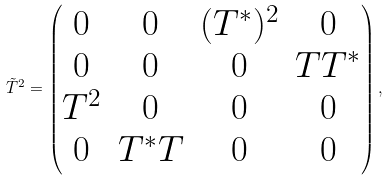<formula> <loc_0><loc_0><loc_500><loc_500>\tilde { T } ^ { 2 } = \begin{pmatrix} 0 & 0 & ( T ^ { * } ) ^ { 2 } & 0 \\ 0 & 0 & 0 & T T ^ { * } \\ T ^ { 2 } & 0 & 0 & 0 \\ 0 & T ^ { * } T & 0 & 0 \end{pmatrix} ,</formula> 